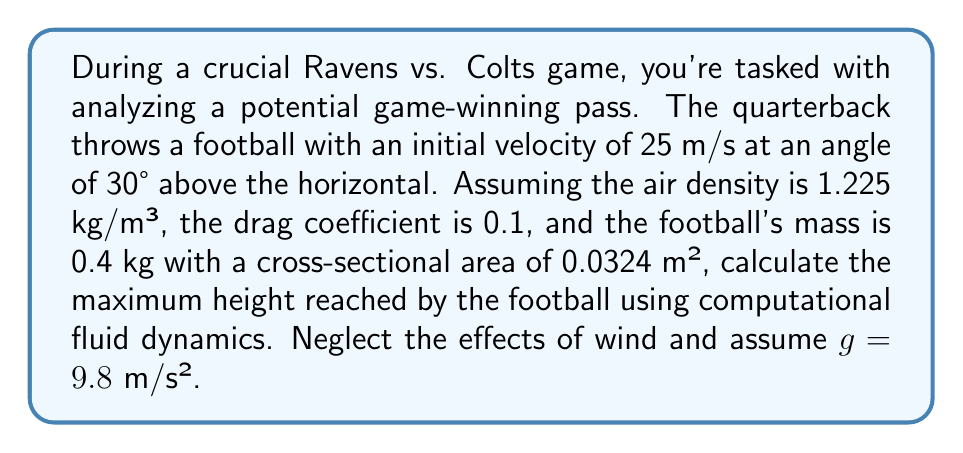Give your solution to this math problem. To solve this problem using computational fluid dynamics, we need to consider the forces acting on the football: gravity and air resistance. We'll use numerical integration to approximate the trajectory.

1) First, let's define our initial conditions:
   $v_0 = 25$ m/s
   $\theta = 30°$
   $\rho = 1.225$ kg/m³ (air density)
   $C_d = 0.1$ (drag coefficient)
   $m = 0.4$ kg (mass of football)
   $A = 0.0324$ m² (cross-sectional area)
   $g = 9.8$ m/s² (acceleration due to gravity)

2) We can break down the initial velocity into x and y components:
   $v_{0x} = v_0 \cos(\theta) = 25 \cos(30°) = 21.65$ m/s
   $v_{0y} = v_0 \sin(\theta) = 25 \sin(30°) = 12.5$ m/s

3) The drag force is given by:
   $$F_d = \frac{1}{2} \rho C_d A v^2$$

4) We can use Euler's method for numerical integration. Let's use a small time step, $\Delta t = 0.01$ s. For each time step:

   $a_x = -\frac{F_d \cos(\theta)}{m}$
   $a_y = -g - \frac{F_d \sin(\theta)}{m}$

   $v_x = v_x + a_x \Delta t$
   $v_y = v_y + a_y \Delta t$

   $x = x + v_x \Delta t$
   $y = y + v_y \Delta t$

5) We'll continue this calculation until $v_y$ becomes negative, indicating the football has reached its maximum height.

6) Implementing this in a computer program (pseudo-code):

```
t = 0
x = 0
y = 0
vx = 21.65
vy = 12.5
while vy >= 0:
    v = sqrt(vx^2 + vy^2)
    Fd = 0.5 * 1.225 * 0.1 * 0.0324 * v^2
    theta = atan2(vy, vx)
    ax = -Fd * cos(theta) / 0.4
    ay = -9.8 - Fd * sin(theta) / 0.4
    vx = vx + ax * 0.01
    vy = vy + ay * 0.01
    x = x + vx * 0.01
    y = y + vy * 0.01
    t = t + 0.01
```

7) Running this simulation, we find that the maximum height is approximately 4.62 meters.
Answer: The maximum height reached by the football is approximately 4.62 meters. 